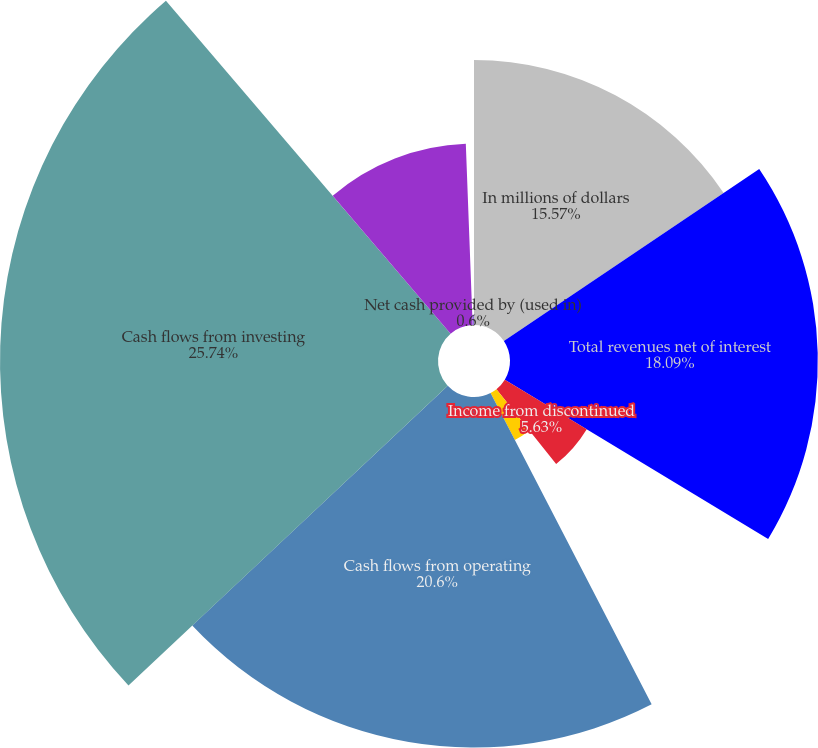Convert chart to OTSL. <chart><loc_0><loc_0><loc_500><loc_500><pie_chart><fcel>In millions of dollars<fcel>Total revenues net of interest<fcel>Income from discontinued<fcel>Provision for income taxes and<fcel>Cash flows from operating<fcel>Cash flows from investing<fcel>Cash flows from financing<fcel>Net cash provided by (used in)<nl><fcel>15.57%<fcel>18.09%<fcel>5.63%<fcel>3.11%<fcel>20.6%<fcel>25.74%<fcel>10.66%<fcel>0.6%<nl></chart> 